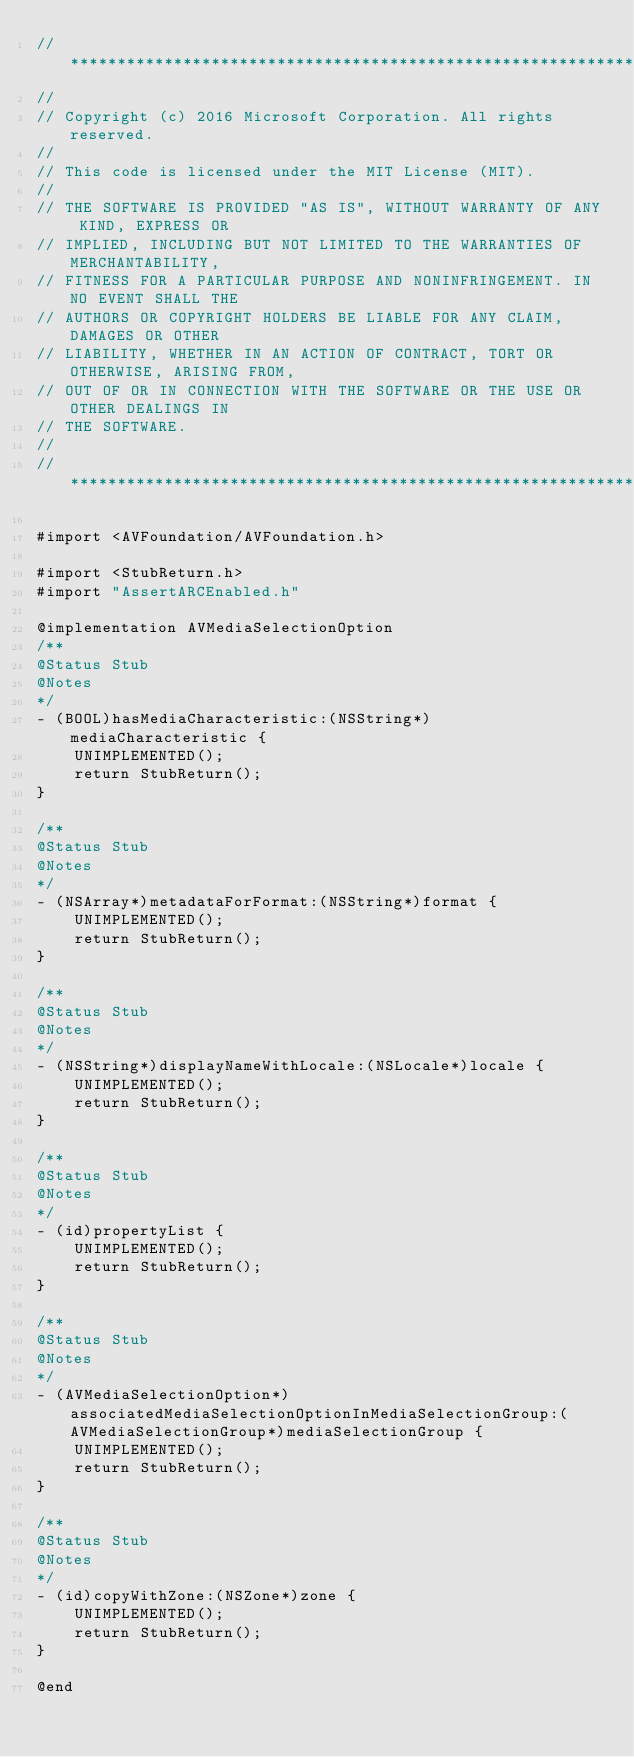Convert code to text. <code><loc_0><loc_0><loc_500><loc_500><_ObjectiveC_>//******************************************************************************
//
// Copyright (c) 2016 Microsoft Corporation. All rights reserved.
//
// This code is licensed under the MIT License (MIT).
//
// THE SOFTWARE IS PROVIDED "AS IS", WITHOUT WARRANTY OF ANY KIND, EXPRESS OR
// IMPLIED, INCLUDING BUT NOT LIMITED TO THE WARRANTIES OF MERCHANTABILITY,
// FITNESS FOR A PARTICULAR PURPOSE AND NONINFRINGEMENT. IN NO EVENT SHALL THE
// AUTHORS OR COPYRIGHT HOLDERS BE LIABLE FOR ANY CLAIM, DAMAGES OR OTHER
// LIABILITY, WHETHER IN AN ACTION OF CONTRACT, TORT OR OTHERWISE, ARISING FROM,
// OUT OF OR IN CONNECTION WITH THE SOFTWARE OR THE USE OR OTHER DEALINGS IN
// THE SOFTWARE.
//
//******************************************************************************

#import <AVFoundation/AVFoundation.h>

#import <StubReturn.h>
#import "AssertARCEnabled.h"

@implementation AVMediaSelectionOption
/**
@Status Stub
@Notes
*/
- (BOOL)hasMediaCharacteristic:(NSString*)mediaCharacteristic {
    UNIMPLEMENTED();
    return StubReturn();
}

/**
@Status Stub
@Notes
*/
- (NSArray*)metadataForFormat:(NSString*)format {
    UNIMPLEMENTED();
    return StubReturn();
}

/**
@Status Stub
@Notes
*/
- (NSString*)displayNameWithLocale:(NSLocale*)locale {
    UNIMPLEMENTED();
    return StubReturn();
}

/**
@Status Stub
@Notes
*/
- (id)propertyList {
    UNIMPLEMENTED();
    return StubReturn();
}

/**
@Status Stub
@Notes
*/
- (AVMediaSelectionOption*)associatedMediaSelectionOptionInMediaSelectionGroup:(AVMediaSelectionGroup*)mediaSelectionGroup {
    UNIMPLEMENTED();
    return StubReturn();
}

/**
@Status Stub
@Notes
*/
- (id)copyWithZone:(NSZone*)zone {
    UNIMPLEMENTED();
    return StubReturn();
}

@end
</code> 